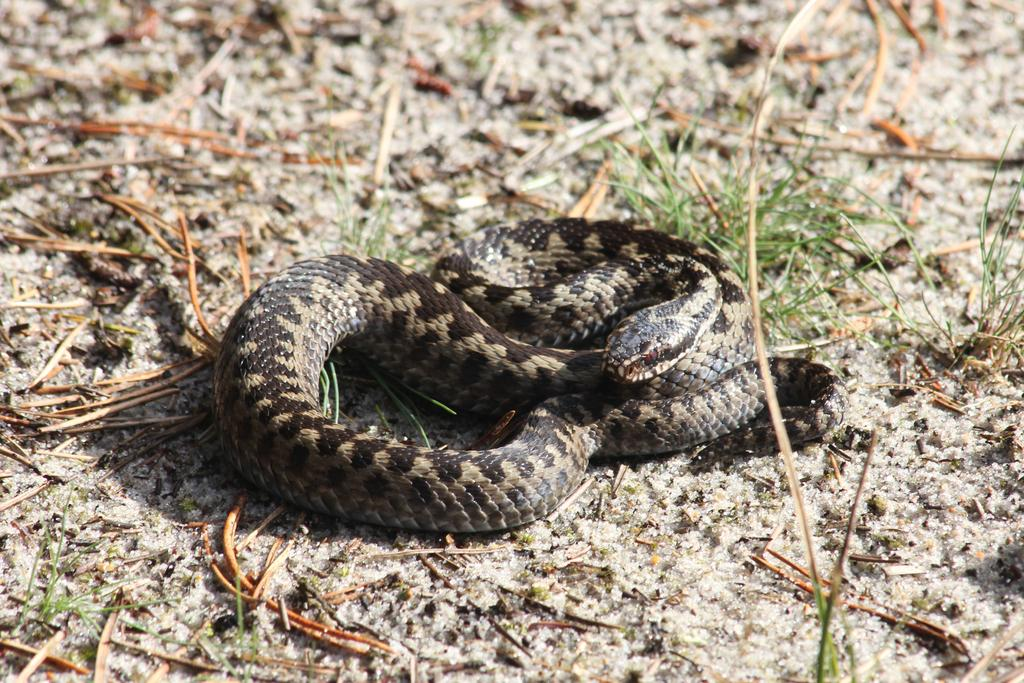What type of vegetation is present in the image? There is grass in the image. What animal can be seen on the ground in the image? There is a snake on the ground in the image. What type of account does the snake have in the image? There is no mention of an account or any financial aspect in the image; it simply features a snake on the grass. 